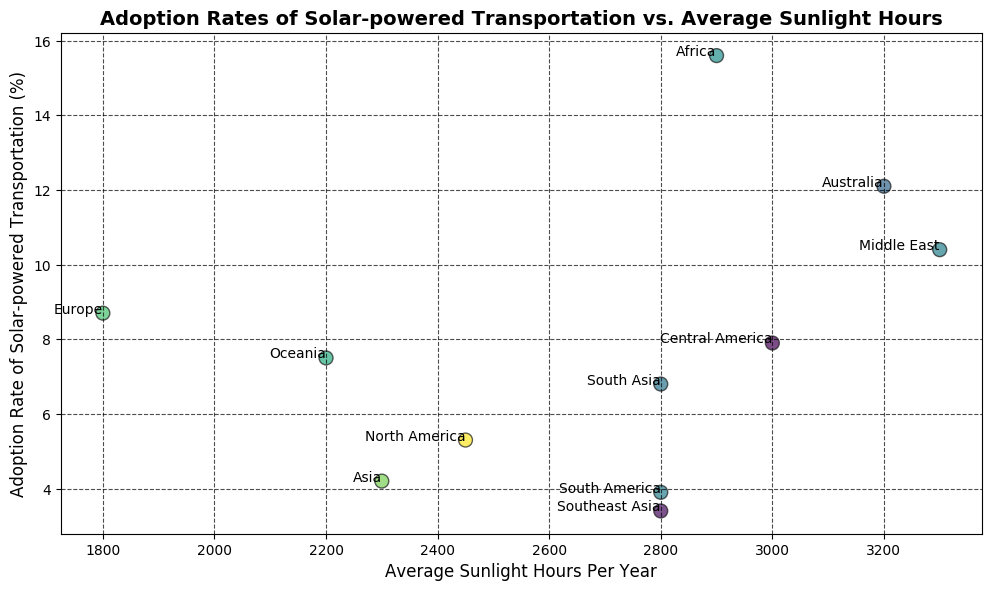Which region has the highest adoption rate of solar-powered transportation? Looking at the plot, the region with the highest position on the y-axis represents the highest adoption rate. Africa has the highest point on the y-axis indicating the highest adoption rate of solar-powered transportation.
Answer: Africa Which region has the lowest adoption rate, and how many sunlight hours does it receive? The region with the lowest point on the y-axis signifies the lowest adoption rate. Southeast Asia is the lowest point and receives around 2800 sunlight hours per year.
Answer: Southeast Asia, 2800 hours What is the average adoption rate of solar-powered transportation for regions with more than 3000 sunlight hours per year? First, identify regions with more than 3000 sunlight hours (Australia, Middle East, Central America). Then, calculate their average adoption rate: (12.1 + 10.4 + 7.9) / 3.
Answer: (12.1+10.4+7.9)/3 = 10.13 Which region has an adoption rate closest to 8% and what is its sunlight hours? Looking at the y-axis values closest to 8%, Europe has an adoption rate of 8.7% with sunlight hours of 1800.
Answer: Europe, 1800 hours How does the adoption rate in Oceania compare to North America? Look at the plot's position for Oceania and North America on the y-axis. Oceania's adoption rate (7.5%) is higher than North America's (5.3%).
Answer: Oceania > North America Which two regions have similar adoption rates but different sunlight hours? Check regions with similar positions on the y-axis but different x-axis positions. South Asia (6.8%, 2800 hours) and Oceania (7.5%, 2200 hours) are close.
Answer: South Asia, Oceania What is the total adoption rate of regions with less than 2500 sunlight hours per year? Identify regions with less than 2500 sunlight hours (North America, Europe, Oceania). Sum their adoption rates: 5.3 + 8.7 + 7.5.
Answer: 5.3+8.7+7.5 = 21.5% Which region receives the maximum sunlight hours, and what is its adoption rate? The region farthest to the right on the x-axis (Middle East) has maximum sunlight hours (3300 hours) and its adoption rate is 10.4%.
Answer: Middle East, 10.4% How many regions have an adoption rate above 10%, and what are they? Identify points above the 10% mark on the y-axis. Three regions: Australia (12.1%), Africa (15.6%), and Middle East (10.4%) have adoption rates above 10%.
Answer: 3 regions: Australia, Africa, Middle East Which region with around 2800 sunlight hours has the lowest adoption rate? Compare the adoption rates for the regions around 2800 sunlight hours. Southeast Asia has an adoption rate of 3.4%, which is the lowest among them.
Answer: Southeast Asia 